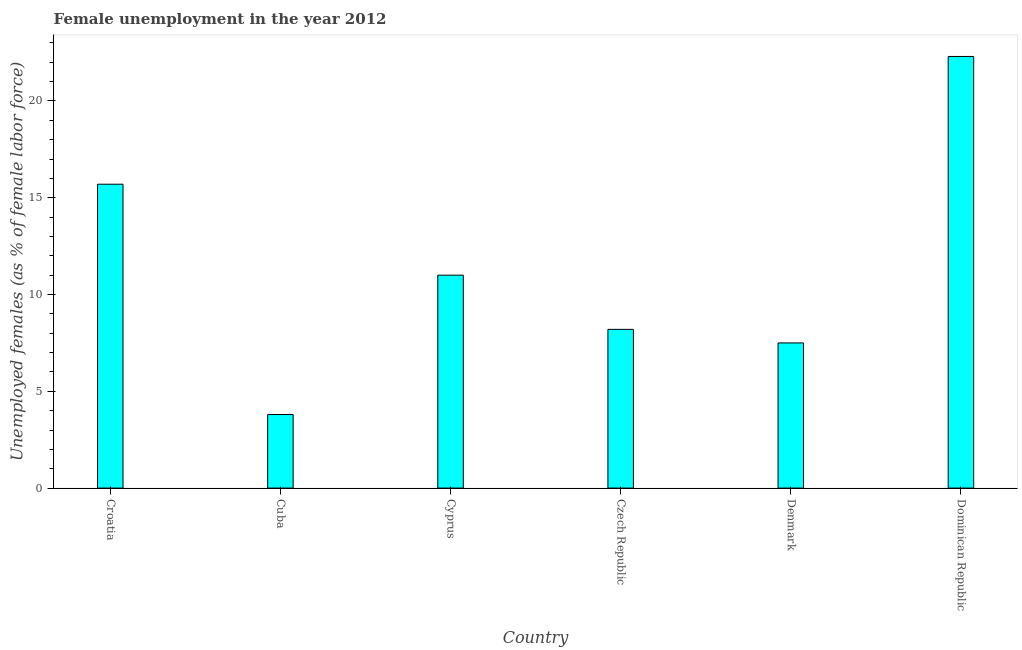Does the graph contain grids?
Your answer should be very brief. No. What is the title of the graph?
Give a very brief answer. Female unemployment in the year 2012. What is the label or title of the Y-axis?
Offer a terse response. Unemployed females (as % of female labor force). What is the unemployed females population in Cuba?
Provide a succinct answer. 3.8. Across all countries, what is the maximum unemployed females population?
Your response must be concise. 22.3. Across all countries, what is the minimum unemployed females population?
Offer a terse response. 3.8. In which country was the unemployed females population maximum?
Ensure brevity in your answer.  Dominican Republic. In which country was the unemployed females population minimum?
Provide a succinct answer. Cuba. What is the sum of the unemployed females population?
Keep it short and to the point. 68.5. What is the difference between the unemployed females population in Croatia and Denmark?
Give a very brief answer. 8.2. What is the average unemployed females population per country?
Ensure brevity in your answer.  11.42. What is the median unemployed females population?
Make the answer very short. 9.6. In how many countries, is the unemployed females population greater than 9 %?
Provide a succinct answer. 3. What is the ratio of the unemployed females population in Cuba to that in Cyprus?
Your response must be concise. 0.34. Is the sum of the unemployed females population in Czech Republic and Dominican Republic greater than the maximum unemployed females population across all countries?
Offer a very short reply. Yes. What is the difference between the highest and the lowest unemployed females population?
Keep it short and to the point. 18.5. In how many countries, is the unemployed females population greater than the average unemployed females population taken over all countries?
Keep it short and to the point. 2. How many bars are there?
Offer a very short reply. 6. Are the values on the major ticks of Y-axis written in scientific E-notation?
Make the answer very short. No. What is the Unemployed females (as % of female labor force) in Croatia?
Your response must be concise. 15.7. What is the Unemployed females (as % of female labor force) of Cuba?
Your response must be concise. 3.8. What is the Unemployed females (as % of female labor force) in Cyprus?
Offer a very short reply. 11. What is the Unemployed females (as % of female labor force) in Czech Republic?
Your response must be concise. 8.2. What is the Unemployed females (as % of female labor force) in Dominican Republic?
Ensure brevity in your answer.  22.3. What is the difference between the Unemployed females (as % of female labor force) in Croatia and Cuba?
Your answer should be compact. 11.9. What is the difference between the Unemployed females (as % of female labor force) in Croatia and Czech Republic?
Ensure brevity in your answer.  7.5. What is the difference between the Unemployed females (as % of female labor force) in Cuba and Cyprus?
Your answer should be compact. -7.2. What is the difference between the Unemployed females (as % of female labor force) in Cuba and Denmark?
Offer a terse response. -3.7. What is the difference between the Unemployed females (as % of female labor force) in Cuba and Dominican Republic?
Your response must be concise. -18.5. What is the difference between the Unemployed females (as % of female labor force) in Cyprus and Denmark?
Your answer should be very brief. 3.5. What is the difference between the Unemployed females (as % of female labor force) in Czech Republic and Dominican Republic?
Your answer should be compact. -14.1. What is the difference between the Unemployed females (as % of female labor force) in Denmark and Dominican Republic?
Your response must be concise. -14.8. What is the ratio of the Unemployed females (as % of female labor force) in Croatia to that in Cuba?
Your answer should be very brief. 4.13. What is the ratio of the Unemployed females (as % of female labor force) in Croatia to that in Cyprus?
Offer a very short reply. 1.43. What is the ratio of the Unemployed females (as % of female labor force) in Croatia to that in Czech Republic?
Make the answer very short. 1.92. What is the ratio of the Unemployed females (as % of female labor force) in Croatia to that in Denmark?
Offer a terse response. 2.09. What is the ratio of the Unemployed females (as % of female labor force) in Croatia to that in Dominican Republic?
Offer a very short reply. 0.7. What is the ratio of the Unemployed females (as % of female labor force) in Cuba to that in Cyprus?
Offer a very short reply. 0.34. What is the ratio of the Unemployed females (as % of female labor force) in Cuba to that in Czech Republic?
Offer a very short reply. 0.46. What is the ratio of the Unemployed females (as % of female labor force) in Cuba to that in Denmark?
Make the answer very short. 0.51. What is the ratio of the Unemployed females (as % of female labor force) in Cuba to that in Dominican Republic?
Make the answer very short. 0.17. What is the ratio of the Unemployed females (as % of female labor force) in Cyprus to that in Czech Republic?
Your answer should be very brief. 1.34. What is the ratio of the Unemployed females (as % of female labor force) in Cyprus to that in Denmark?
Make the answer very short. 1.47. What is the ratio of the Unemployed females (as % of female labor force) in Cyprus to that in Dominican Republic?
Offer a very short reply. 0.49. What is the ratio of the Unemployed females (as % of female labor force) in Czech Republic to that in Denmark?
Keep it short and to the point. 1.09. What is the ratio of the Unemployed females (as % of female labor force) in Czech Republic to that in Dominican Republic?
Your answer should be very brief. 0.37. What is the ratio of the Unemployed females (as % of female labor force) in Denmark to that in Dominican Republic?
Give a very brief answer. 0.34. 